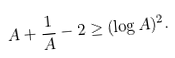<formula> <loc_0><loc_0><loc_500><loc_500>A + \frac { 1 } { A } - 2 \geq ( \log A ) ^ { 2 } .</formula> 